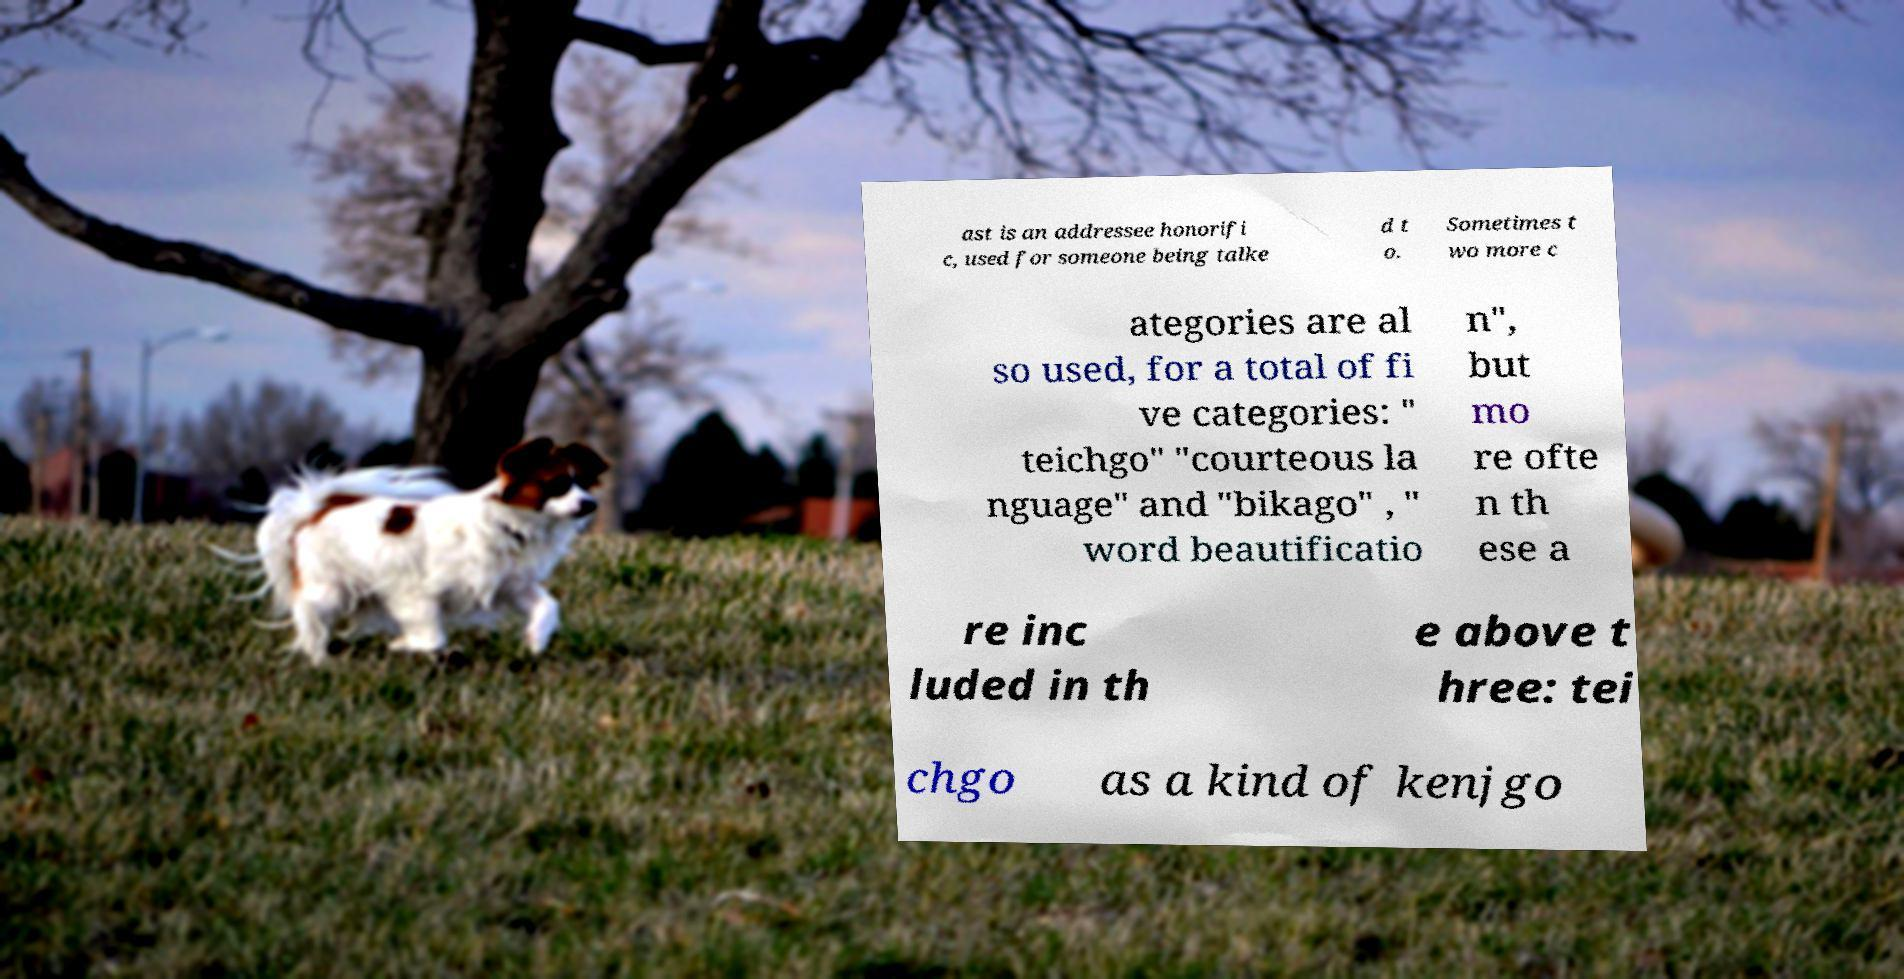Could you extract and type out the text from this image? ast is an addressee honorifi c, used for someone being talke d t o. Sometimes t wo more c ategories are al so used, for a total of fi ve categories: " teichgo" "courteous la nguage" and "bikago" , " word beautificatio n", but mo re ofte n th ese a re inc luded in th e above t hree: tei chgo as a kind of kenjgo 